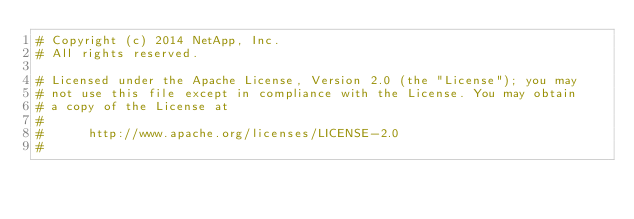<code> <loc_0><loc_0><loc_500><loc_500><_Python_># Copyright (c) 2014 NetApp, Inc.
# All rights reserved.

# Licensed under the Apache License, Version 2.0 (the "License"); you may
# not use this file except in compliance with the License. You may obtain
# a copy of the License at
#
#      http://www.apache.org/licenses/LICENSE-2.0
#</code> 